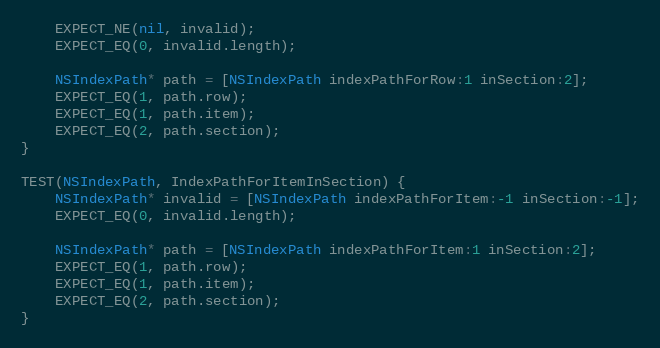<code> <loc_0><loc_0><loc_500><loc_500><_ObjectiveC_>    EXPECT_NE(nil, invalid);
    EXPECT_EQ(0, invalid.length);

    NSIndexPath* path = [NSIndexPath indexPathForRow:1 inSection:2];
    EXPECT_EQ(1, path.row);
    EXPECT_EQ(1, path.item);
    EXPECT_EQ(2, path.section);
}

TEST(NSIndexPath, IndexPathForItemInSection) {
    NSIndexPath* invalid = [NSIndexPath indexPathForItem:-1 inSection:-1];
    EXPECT_EQ(0, invalid.length);

    NSIndexPath* path = [NSIndexPath indexPathForItem:1 inSection:2];
    EXPECT_EQ(1, path.row);
    EXPECT_EQ(1, path.item);
    EXPECT_EQ(2, path.section);
}</code> 